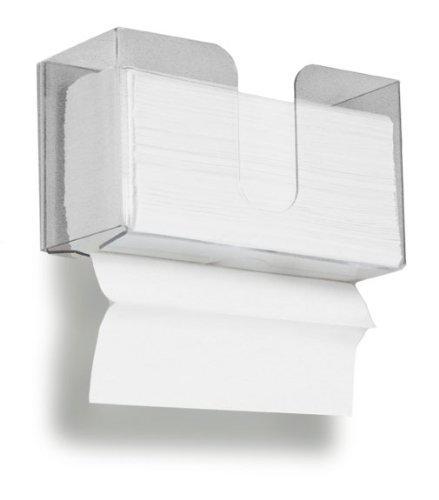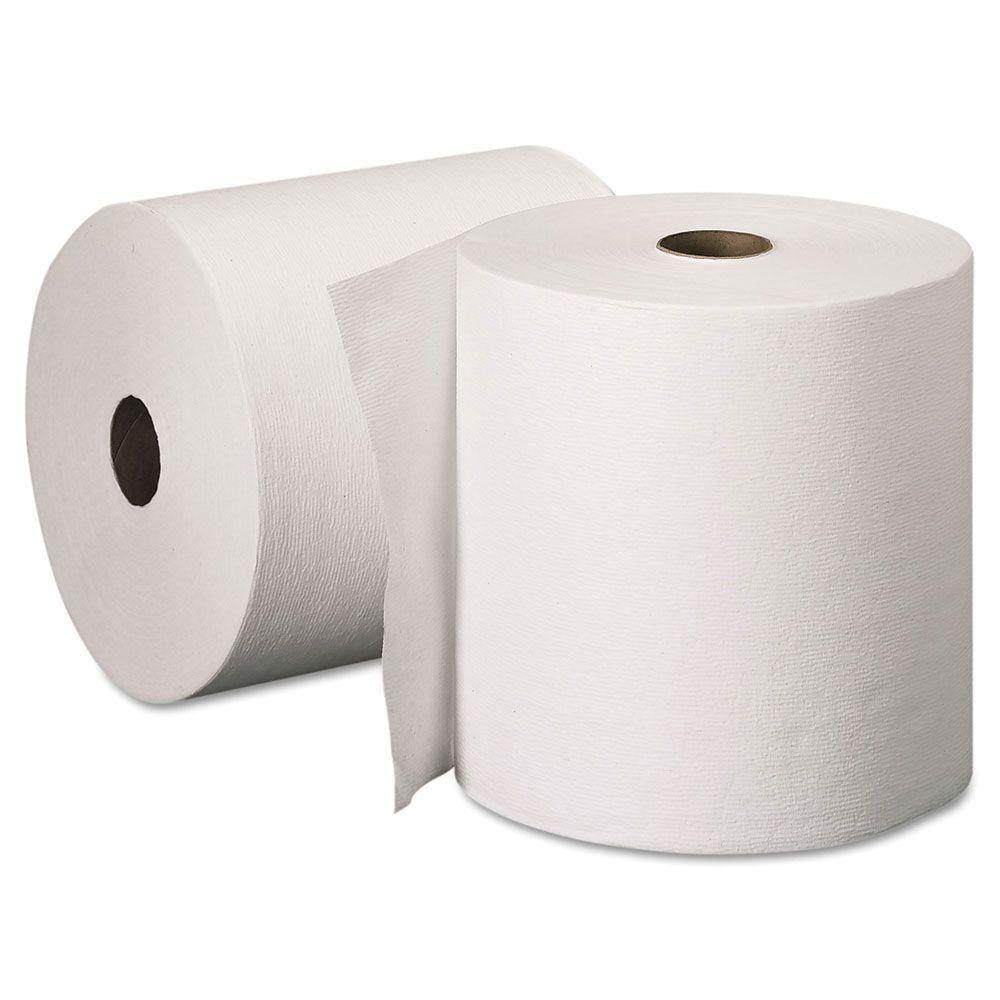The first image is the image on the left, the second image is the image on the right. Evaluate the accuracy of this statement regarding the images: "Each image shows a white paper roll hung on a dispenser.". Is it true? Answer yes or no. No. The first image is the image on the left, the second image is the image on the right. Given the left and right images, does the statement "Each roll of toilet paper is hanging on a dispenser." hold true? Answer yes or no. No. 